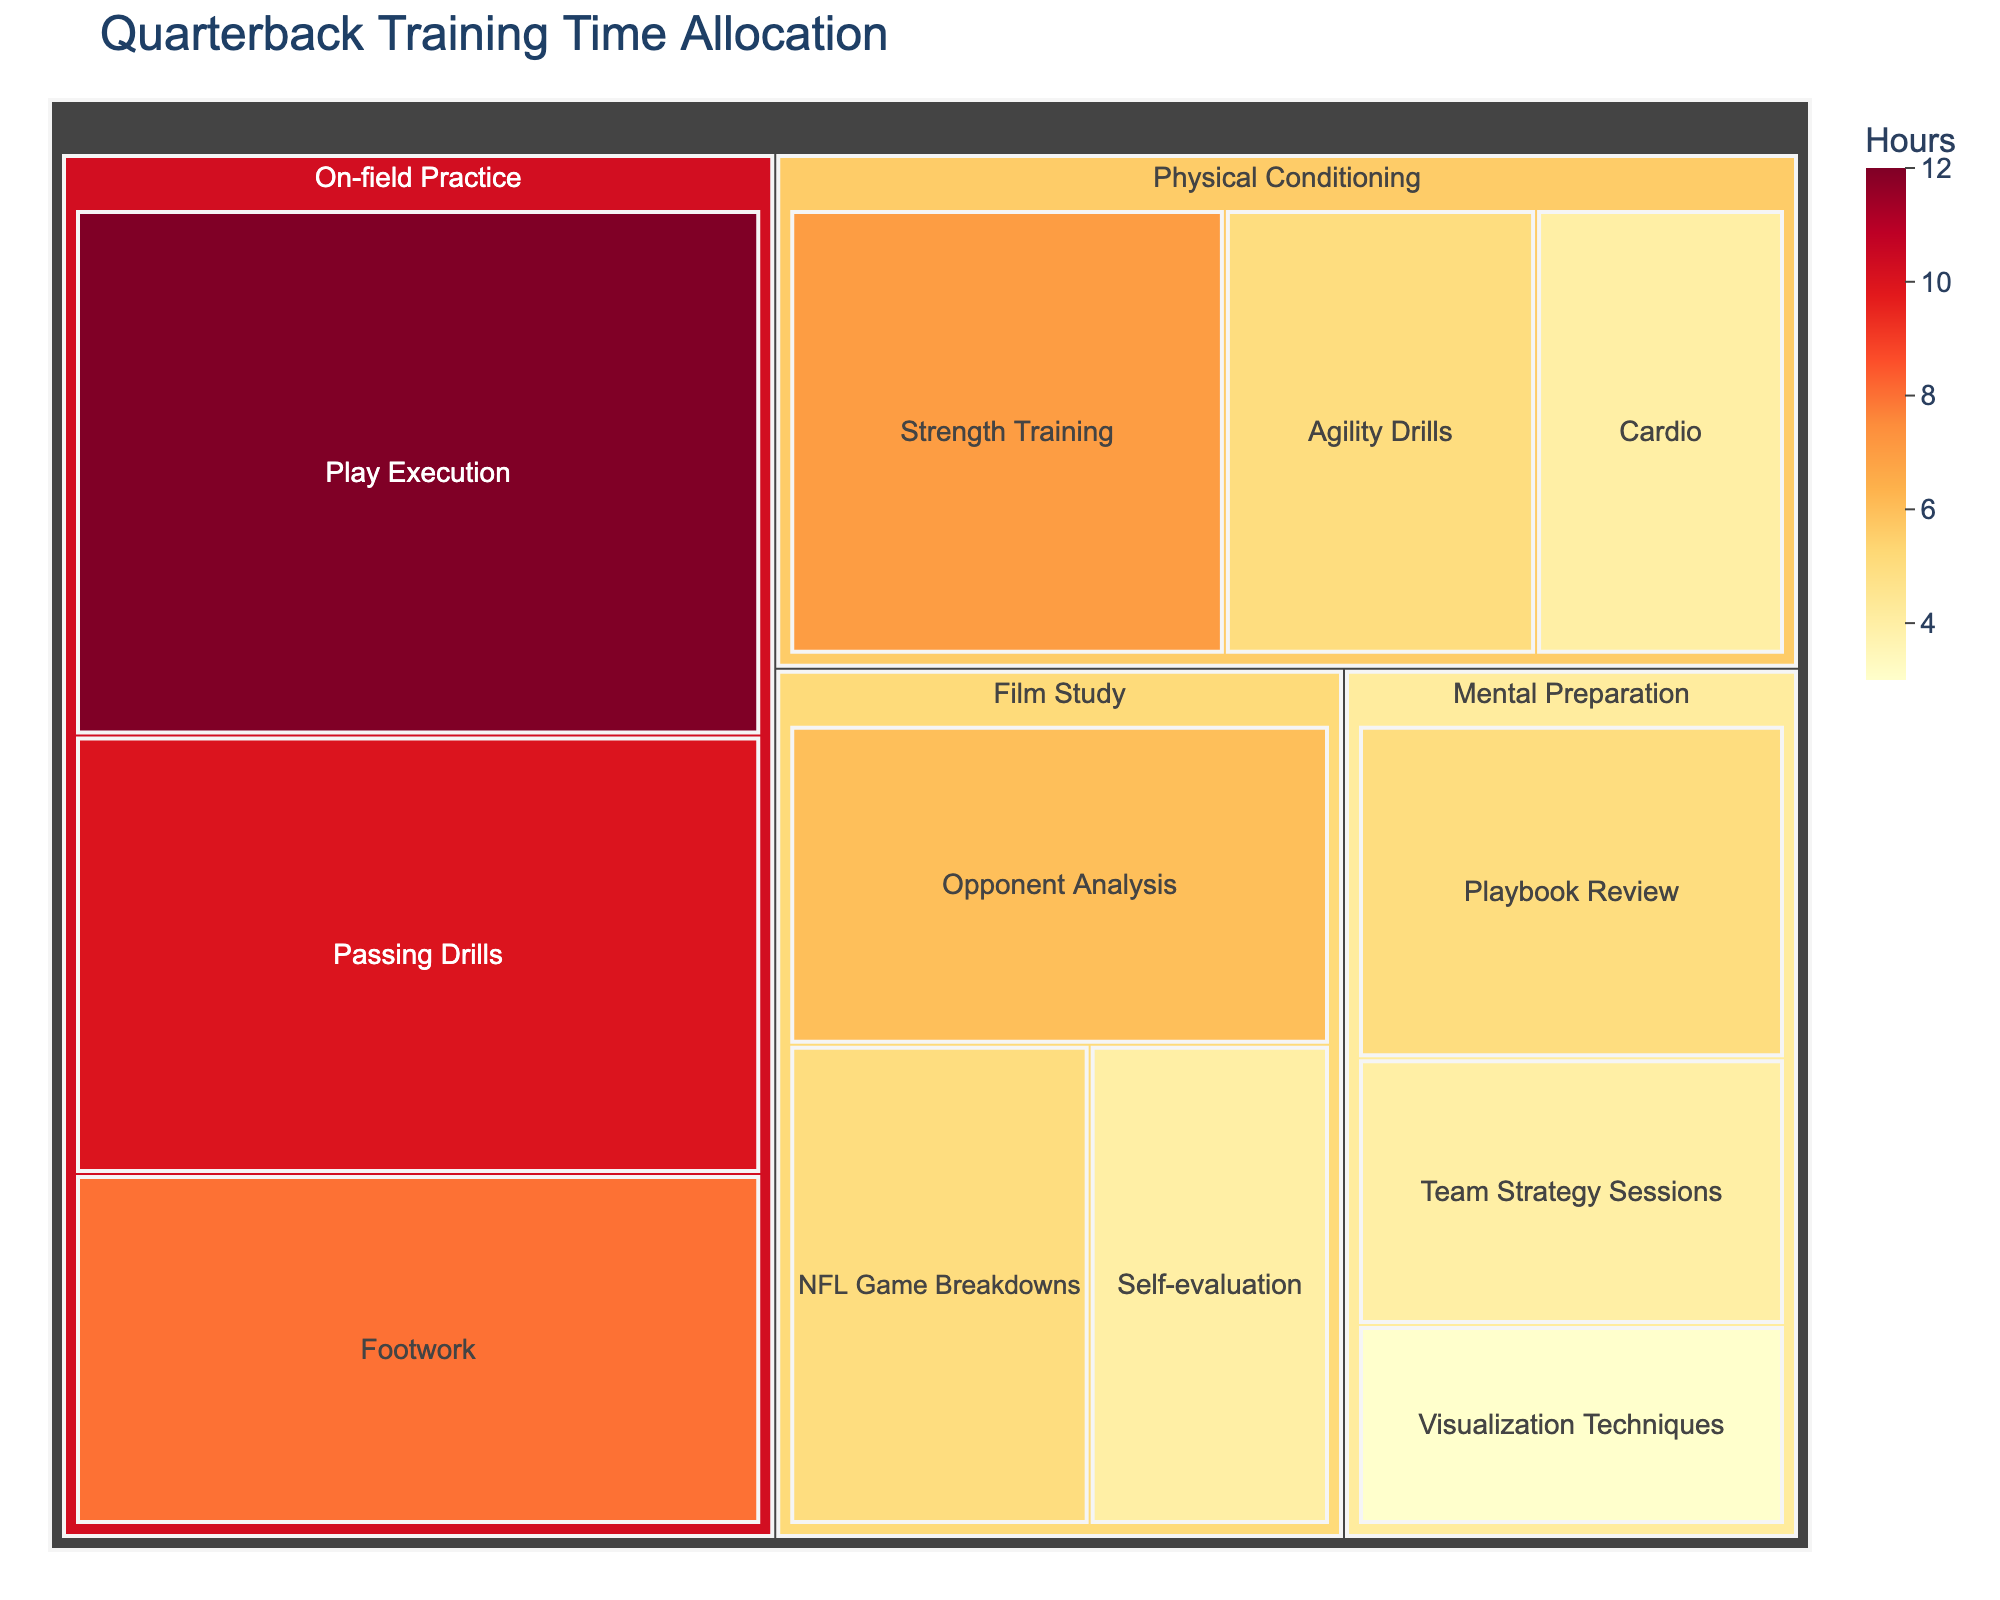Which category has the highest total hours? To determine which category has the highest total hours, sum the hours for all subcategories within each category, and then compare the totals. On-field Practice: 10 + 8 + 12 = 30; Film Study: 6 + 4 + 5 = 15; Physical Conditioning: 7 + 5 + 4 = 16; Mental Preparation: 3 + 5 + 4 = 12. Hence, On-field Practice has the highest total hours.
Answer: On-field Practice How many hours are spent on Mental Preparation in total? Sum the hours for all subcategories under Mental Preparation to find the total. Visualization Techniques: 3; Playbook Review: 5; Team Strategy Sessions: 4. So, 3 + 5 + 4 = 12.
Answer: 12 Which activity within Physical Conditioning takes up the most hours? Compare the hours assigned to each subcategory within Physical Conditioning. Strength Training: 7, Agility Drills: 5, Cardio: 4. Strength Training takes up the most hours.
Answer: Strength Training How does the time spent on Play Execution compare to the time spent on Opponent Analysis? Compare the hours for Play Execution with those for Opponent Analysis. Play Execution: 12 hours, Opponent Analysis: 6 hours. Play Execution has more hours.
Answer: Play Execution has more hours What is the sum of hours allocated to both Passing Drills and Footwork? Add the hours for Passing Drills and Footwork together. Passing Drills: 10; Footwork: 8. So, 10 + 8 = 18.
Answer: 18 Which has more hours, NFL Game Breakdowns or Cardio? Compare the hours for NFL Game Breakdowns and Cardio. NFL Game Breakdowns: 5; Cardio: 4. NFL Game Breakdowns has more hours.
Answer: NFL Game Breakdowns What percentage of total On-field Practice time is spent on Footwork? First, find the total hours for On-field Practice: 10 (Passing Drills) + 8 (Footwork) + 12 (Play Execution) = 30. Then, calculate the percentage: (8 / 30) * 100.
Answer: Approximately 26.67% What is the average time spent on Film Study activities? First, find the total hours assigned to Film Study: 6 (Opponent Analysis) + 4 (Self-evaluation) + 5 (NFL Game Breakdowns) = 15. Then, calculate the average by dividing this sum by the number of subcategories in Film Study: 15 / 3 = 5.
Answer: 5 For Mental Preparation, is more time spent on Playbook Review or Team Strategy Sessions? Compare the hours for Playbook Review and Team Strategy Sessions. Playbook Review: 5; Team Strategy Sessions: 4. Therefore, more time is spent on Playbook Review.
Answer: Playbook Review Between Strength Training and Play Execution, which has fewer hours, and by how much? Compare the hours for Strength Training and Play Execution. Strength Training: 7 hours, Play Execution: 12 hours. Strength Training has fewer hours, and the difference is 12 - 7 = 5 hours.
Answer: Strength Training by 5 hours 